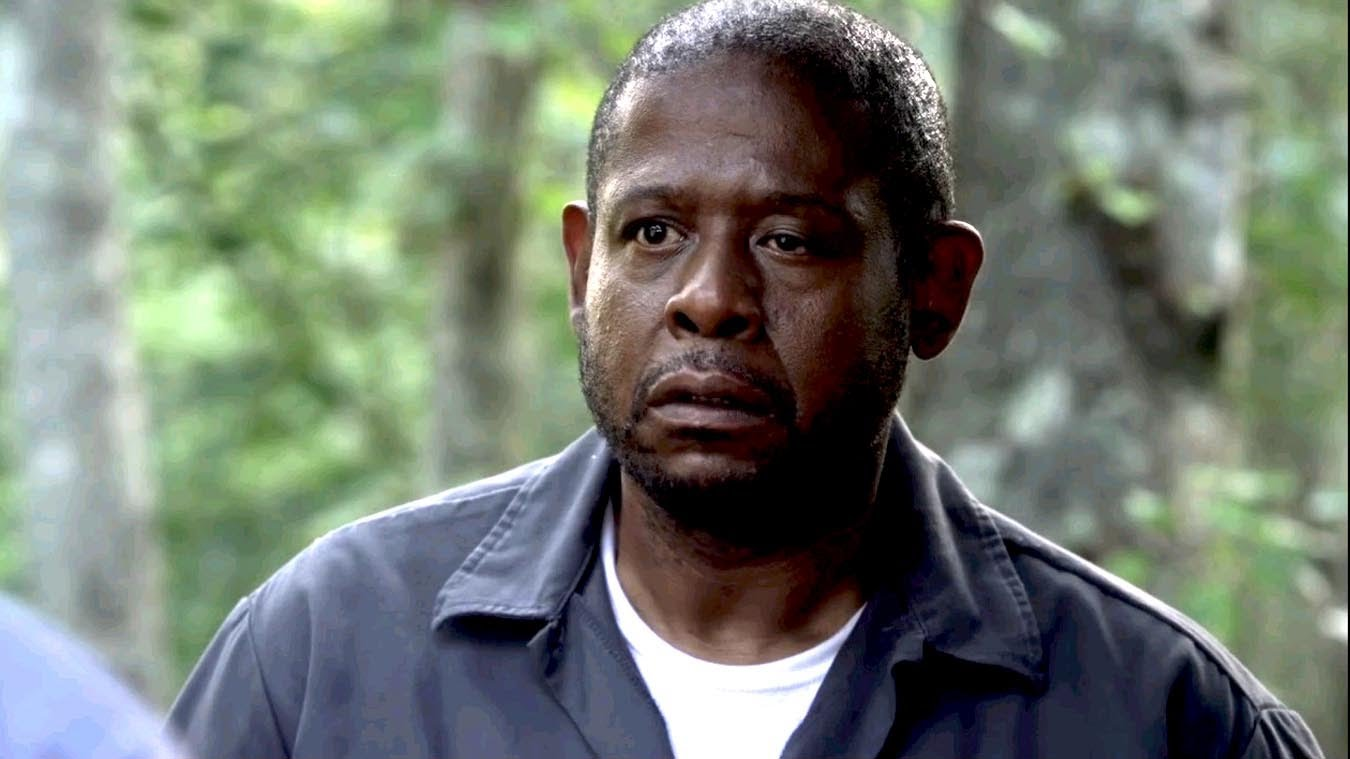Can you describe the choice of clothing for this character and its implications for the scene? The character is dressed in a simple yet practical dark jacket and shirt, suggesting a readiness to engage with the physical environment or an unfolding situation that requires agility and adaptability. This attire complements the rugged outdoor setting and hints that his role might involve active physical engagement or a readiness to confront challenges head-on. 